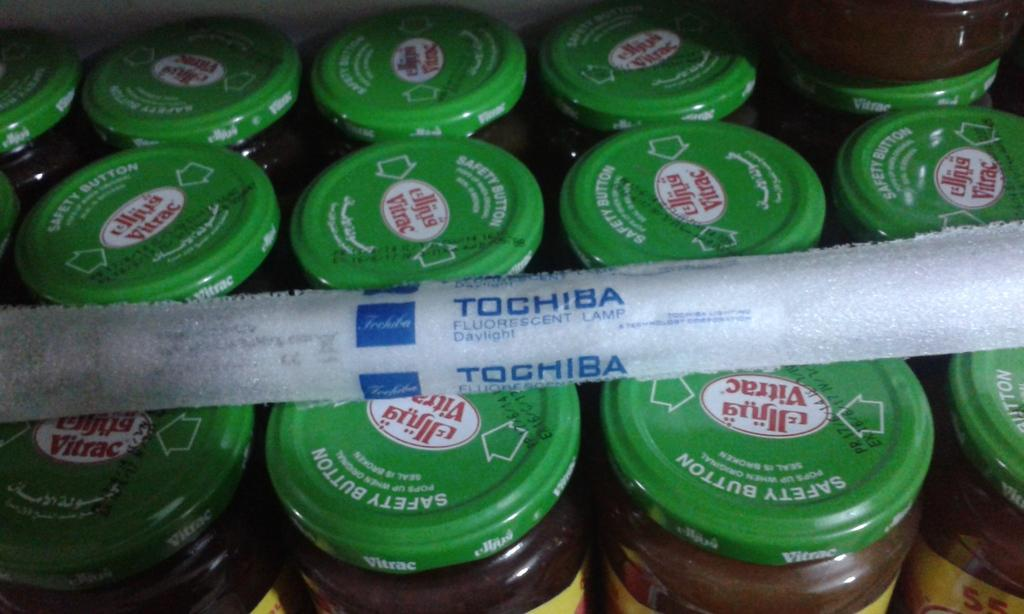<image>
Summarize the visual content of the image. A Tochiba fluorescent lamp on top of a bunch of jars. 